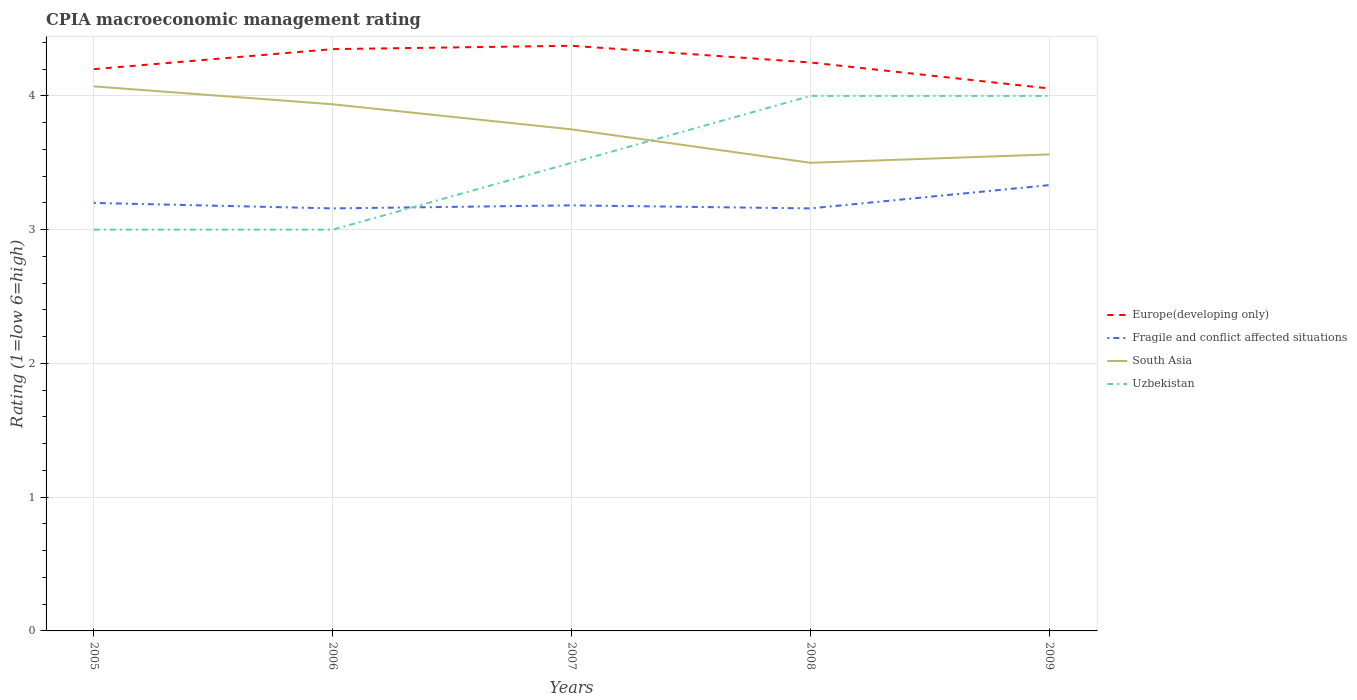How many different coloured lines are there?
Give a very brief answer. 4. Does the line corresponding to Fragile and conflict affected situations intersect with the line corresponding to Uzbekistan?
Your answer should be very brief. Yes. Is the number of lines equal to the number of legend labels?
Provide a short and direct response. Yes. Across all years, what is the maximum CPIA rating in Europe(developing only)?
Provide a short and direct response. 4.06. In which year was the CPIA rating in Uzbekistan maximum?
Keep it short and to the point. 2005. What is the difference between the highest and the second highest CPIA rating in Fragile and conflict affected situations?
Give a very brief answer. 0.17. How many lines are there?
Keep it short and to the point. 4. How many years are there in the graph?
Your response must be concise. 5. What is the difference between two consecutive major ticks on the Y-axis?
Ensure brevity in your answer.  1. Does the graph contain any zero values?
Ensure brevity in your answer.  No. What is the title of the graph?
Offer a very short reply. CPIA macroeconomic management rating. What is the label or title of the X-axis?
Provide a succinct answer. Years. What is the label or title of the Y-axis?
Offer a very short reply. Rating (1=low 6=high). What is the Rating (1=low 6=high) of Europe(developing only) in 2005?
Give a very brief answer. 4.2. What is the Rating (1=low 6=high) of Fragile and conflict affected situations in 2005?
Give a very brief answer. 3.2. What is the Rating (1=low 6=high) of South Asia in 2005?
Offer a very short reply. 4.07. What is the Rating (1=low 6=high) in Uzbekistan in 2005?
Ensure brevity in your answer.  3. What is the Rating (1=low 6=high) of Europe(developing only) in 2006?
Keep it short and to the point. 4.35. What is the Rating (1=low 6=high) in Fragile and conflict affected situations in 2006?
Your response must be concise. 3.16. What is the Rating (1=low 6=high) of South Asia in 2006?
Your answer should be compact. 3.94. What is the Rating (1=low 6=high) in Europe(developing only) in 2007?
Your answer should be compact. 4.38. What is the Rating (1=low 6=high) of Fragile and conflict affected situations in 2007?
Provide a short and direct response. 3.18. What is the Rating (1=low 6=high) in South Asia in 2007?
Give a very brief answer. 3.75. What is the Rating (1=low 6=high) of Uzbekistan in 2007?
Provide a succinct answer. 3.5. What is the Rating (1=low 6=high) in Europe(developing only) in 2008?
Provide a short and direct response. 4.25. What is the Rating (1=low 6=high) in Fragile and conflict affected situations in 2008?
Your answer should be compact. 3.16. What is the Rating (1=low 6=high) of Europe(developing only) in 2009?
Provide a short and direct response. 4.06. What is the Rating (1=low 6=high) of Fragile and conflict affected situations in 2009?
Offer a terse response. 3.33. What is the Rating (1=low 6=high) in South Asia in 2009?
Give a very brief answer. 3.56. Across all years, what is the maximum Rating (1=low 6=high) of Europe(developing only)?
Ensure brevity in your answer.  4.38. Across all years, what is the maximum Rating (1=low 6=high) in Fragile and conflict affected situations?
Make the answer very short. 3.33. Across all years, what is the maximum Rating (1=low 6=high) of South Asia?
Provide a succinct answer. 4.07. Across all years, what is the maximum Rating (1=low 6=high) of Uzbekistan?
Offer a very short reply. 4. Across all years, what is the minimum Rating (1=low 6=high) of Europe(developing only)?
Keep it short and to the point. 4.06. Across all years, what is the minimum Rating (1=low 6=high) in Fragile and conflict affected situations?
Give a very brief answer. 3.16. Across all years, what is the minimum Rating (1=low 6=high) in South Asia?
Your answer should be very brief. 3.5. Across all years, what is the minimum Rating (1=low 6=high) of Uzbekistan?
Keep it short and to the point. 3. What is the total Rating (1=low 6=high) in Europe(developing only) in the graph?
Your response must be concise. 21.23. What is the total Rating (1=low 6=high) of Fragile and conflict affected situations in the graph?
Give a very brief answer. 16.03. What is the total Rating (1=low 6=high) of South Asia in the graph?
Your answer should be compact. 18.82. What is the difference between the Rating (1=low 6=high) in Europe(developing only) in 2005 and that in 2006?
Your answer should be very brief. -0.15. What is the difference between the Rating (1=low 6=high) in Fragile and conflict affected situations in 2005 and that in 2006?
Offer a very short reply. 0.04. What is the difference between the Rating (1=low 6=high) of South Asia in 2005 and that in 2006?
Offer a very short reply. 0.13. What is the difference between the Rating (1=low 6=high) of Europe(developing only) in 2005 and that in 2007?
Provide a succinct answer. -0.17. What is the difference between the Rating (1=low 6=high) of Fragile and conflict affected situations in 2005 and that in 2007?
Ensure brevity in your answer.  0.02. What is the difference between the Rating (1=low 6=high) in South Asia in 2005 and that in 2007?
Your response must be concise. 0.32. What is the difference between the Rating (1=low 6=high) in Fragile and conflict affected situations in 2005 and that in 2008?
Your response must be concise. 0.04. What is the difference between the Rating (1=low 6=high) in South Asia in 2005 and that in 2008?
Give a very brief answer. 0.57. What is the difference between the Rating (1=low 6=high) of Uzbekistan in 2005 and that in 2008?
Your answer should be compact. -1. What is the difference between the Rating (1=low 6=high) in Europe(developing only) in 2005 and that in 2009?
Provide a short and direct response. 0.14. What is the difference between the Rating (1=low 6=high) in Fragile and conflict affected situations in 2005 and that in 2009?
Your answer should be compact. -0.13. What is the difference between the Rating (1=low 6=high) in South Asia in 2005 and that in 2009?
Provide a short and direct response. 0.51. What is the difference between the Rating (1=low 6=high) of Europe(developing only) in 2006 and that in 2007?
Ensure brevity in your answer.  -0.03. What is the difference between the Rating (1=low 6=high) in Fragile and conflict affected situations in 2006 and that in 2007?
Keep it short and to the point. -0.02. What is the difference between the Rating (1=low 6=high) in South Asia in 2006 and that in 2007?
Provide a short and direct response. 0.19. What is the difference between the Rating (1=low 6=high) of South Asia in 2006 and that in 2008?
Ensure brevity in your answer.  0.44. What is the difference between the Rating (1=low 6=high) of Uzbekistan in 2006 and that in 2008?
Ensure brevity in your answer.  -1. What is the difference between the Rating (1=low 6=high) of Europe(developing only) in 2006 and that in 2009?
Your answer should be very brief. 0.29. What is the difference between the Rating (1=low 6=high) in Fragile and conflict affected situations in 2006 and that in 2009?
Provide a succinct answer. -0.17. What is the difference between the Rating (1=low 6=high) in South Asia in 2006 and that in 2009?
Provide a succinct answer. 0.38. What is the difference between the Rating (1=low 6=high) in Fragile and conflict affected situations in 2007 and that in 2008?
Your response must be concise. 0.02. What is the difference between the Rating (1=low 6=high) of Europe(developing only) in 2007 and that in 2009?
Provide a short and direct response. 0.32. What is the difference between the Rating (1=low 6=high) in Fragile and conflict affected situations in 2007 and that in 2009?
Your answer should be compact. -0.15. What is the difference between the Rating (1=low 6=high) in South Asia in 2007 and that in 2009?
Give a very brief answer. 0.19. What is the difference between the Rating (1=low 6=high) of Europe(developing only) in 2008 and that in 2009?
Offer a terse response. 0.19. What is the difference between the Rating (1=low 6=high) of Fragile and conflict affected situations in 2008 and that in 2009?
Provide a succinct answer. -0.17. What is the difference between the Rating (1=low 6=high) of South Asia in 2008 and that in 2009?
Offer a terse response. -0.06. What is the difference between the Rating (1=low 6=high) of Uzbekistan in 2008 and that in 2009?
Offer a terse response. 0. What is the difference between the Rating (1=low 6=high) of Europe(developing only) in 2005 and the Rating (1=low 6=high) of Fragile and conflict affected situations in 2006?
Your answer should be very brief. 1.04. What is the difference between the Rating (1=low 6=high) in Europe(developing only) in 2005 and the Rating (1=low 6=high) in South Asia in 2006?
Your response must be concise. 0.26. What is the difference between the Rating (1=low 6=high) in Fragile and conflict affected situations in 2005 and the Rating (1=low 6=high) in South Asia in 2006?
Give a very brief answer. -0.74. What is the difference between the Rating (1=low 6=high) of South Asia in 2005 and the Rating (1=low 6=high) of Uzbekistan in 2006?
Offer a very short reply. 1.07. What is the difference between the Rating (1=low 6=high) of Europe(developing only) in 2005 and the Rating (1=low 6=high) of Fragile and conflict affected situations in 2007?
Your answer should be very brief. 1.02. What is the difference between the Rating (1=low 6=high) in Europe(developing only) in 2005 and the Rating (1=low 6=high) in South Asia in 2007?
Your answer should be very brief. 0.45. What is the difference between the Rating (1=low 6=high) in Europe(developing only) in 2005 and the Rating (1=low 6=high) in Uzbekistan in 2007?
Provide a short and direct response. 0.7. What is the difference between the Rating (1=low 6=high) of Fragile and conflict affected situations in 2005 and the Rating (1=low 6=high) of South Asia in 2007?
Offer a terse response. -0.55. What is the difference between the Rating (1=low 6=high) in Fragile and conflict affected situations in 2005 and the Rating (1=low 6=high) in Uzbekistan in 2007?
Provide a short and direct response. -0.3. What is the difference between the Rating (1=low 6=high) in Europe(developing only) in 2005 and the Rating (1=low 6=high) in Fragile and conflict affected situations in 2008?
Your answer should be very brief. 1.04. What is the difference between the Rating (1=low 6=high) in Europe(developing only) in 2005 and the Rating (1=low 6=high) in Uzbekistan in 2008?
Your answer should be very brief. 0.2. What is the difference between the Rating (1=low 6=high) in South Asia in 2005 and the Rating (1=low 6=high) in Uzbekistan in 2008?
Provide a succinct answer. 0.07. What is the difference between the Rating (1=low 6=high) in Europe(developing only) in 2005 and the Rating (1=low 6=high) in Fragile and conflict affected situations in 2009?
Ensure brevity in your answer.  0.87. What is the difference between the Rating (1=low 6=high) of Europe(developing only) in 2005 and the Rating (1=low 6=high) of South Asia in 2009?
Your answer should be compact. 0.64. What is the difference between the Rating (1=low 6=high) in Fragile and conflict affected situations in 2005 and the Rating (1=low 6=high) in South Asia in 2009?
Make the answer very short. -0.36. What is the difference between the Rating (1=low 6=high) in South Asia in 2005 and the Rating (1=low 6=high) in Uzbekistan in 2009?
Offer a very short reply. 0.07. What is the difference between the Rating (1=low 6=high) of Europe(developing only) in 2006 and the Rating (1=low 6=high) of Fragile and conflict affected situations in 2007?
Provide a succinct answer. 1.17. What is the difference between the Rating (1=low 6=high) of Europe(developing only) in 2006 and the Rating (1=low 6=high) of South Asia in 2007?
Offer a very short reply. 0.6. What is the difference between the Rating (1=low 6=high) of Fragile and conflict affected situations in 2006 and the Rating (1=low 6=high) of South Asia in 2007?
Offer a terse response. -0.59. What is the difference between the Rating (1=low 6=high) of Fragile and conflict affected situations in 2006 and the Rating (1=low 6=high) of Uzbekistan in 2007?
Your answer should be compact. -0.34. What is the difference between the Rating (1=low 6=high) of South Asia in 2006 and the Rating (1=low 6=high) of Uzbekistan in 2007?
Your answer should be compact. 0.44. What is the difference between the Rating (1=low 6=high) of Europe(developing only) in 2006 and the Rating (1=low 6=high) of Fragile and conflict affected situations in 2008?
Provide a short and direct response. 1.19. What is the difference between the Rating (1=low 6=high) of Fragile and conflict affected situations in 2006 and the Rating (1=low 6=high) of South Asia in 2008?
Your answer should be compact. -0.34. What is the difference between the Rating (1=low 6=high) of Fragile and conflict affected situations in 2006 and the Rating (1=low 6=high) of Uzbekistan in 2008?
Your response must be concise. -0.84. What is the difference between the Rating (1=low 6=high) of South Asia in 2006 and the Rating (1=low 6=high) of Uzbekistan in 2008?
Give a very brief answer. -0.06. What is the difference between the Rating (1=low 6=high) of Europe(developing only) in 2006 and the Rating (1=low 6=high) of Fragile and conflict affected situations in 2009?
Provide a short and direct response. 1.02. What is the difference between the Rating (1=low 6=high) in Europe(developing only) in 2006 and the Rating (1=low 6=high) in South Asia in 2009?
Your answer should be very brief. 0.79. What is the difference between the Rating (1=low 6=high) of Europe(developing only) in 2006 and the Rating (1=low 6=high) of Uzbekistan in 2009?
Give a very brief answer. 0.35. What is the difference between the Rating (1=low 6=high) of Fragile and conflict affected situations in 2006 and the Rating (1=low 6=high) of South Asia in 2009?
Keep it short and to the point. -0.4. What is the difference between the Rating (1=low 6=high) of Fragile and conflict affected situations in 2006 and the Rating (1=low 6=high) of Uzbekistan in 2009?
Ensure brevity in your answer.  -0.84. What is the difference between the Rating (1=low 6=high) of South Asia in 2006 and the Rating (1=low 6=high) of Uzbekistan in 2009?
Keep it short and to the point. -0.06. What is the difference between the Rating (1=low 6=high) of Europe(developing only) in 2007 and the Rating (1=low 6=high) of Fragile and conflict affected situations in 2008?
Make the answer very short. 1.22. What is the difference between the Rating (1=low 6=high) in Fragile and conflict affected situations in 2007 and the Rating (1=low 6=high) in South Asia in 2008?
Your response must be concise. -0.32. What is the difference between the Rating (1=low 6=high) in Fragile and conflict affected situations in 2007 and the Rating (1=low 6=high) in Uzbekistan in 2008?
Make the answer very short. -0.82. What is the difference between the Rating (1=low 6=high) in Europe(developing only) in 2007 and the Rating (1=low 6=high) in Fragile and conflict affected situations in 2009?
Your answer should be very brief. 1.04. What is the difference between the Rating (1=low 6=high) in Europe(developing only) in 2007 and the Rating (1=low 6=high) in South Asia in 2009?
Your answer should be compact. 0.81. What is the difference between the Rating (1=low 6=high) of Europe(developing only) in 2007 and the Rating (1=low 6=high) of Uzbekistan in 2009?
Your answer should be very brief. 0.38. What is the difference between the Rating (1=low 6=high) in Fragile and conflict affected situations in 2007 and the Rating (1=low 6=high) in South Asia in 2009?
Offer a terse response. -0.38. What is the difference between the Rating (1=low 6=high) in Fragile and conflict affected situations in 2007 and the Rating (1=low 6=high) in Uzbekistan in 2009?
Offer a terse response. -0.82. What is the difference between the Rating (1=low 6=high) in Europe(developing only) in 2008 and the Rating (1=low 6=high) in South Asia in 2009?
Provide a short and direct response. 0.69. What is the difference between the Rating (1=low 6=high) of Europe(developing only) in 2008 and the Rating (1=low 6=high) of Uzbekistan in 2009?
Ensure brevity in your answer.  0.25. What is the difference between the Rating (1=low 6=high) of Fragile and conflict affected situations in 2008 and the Rating (1=low 6=high) of South Asia in 2009?
Your response must be concise. -0.4. What is the difference between the Rating (1=low 6=high) of Fragile and conflict affected situations in 2008 and the Rating (1=low 6=high) of Uzbekistan in 2009?
Offer a very short reply. -0.84. What is the average Rating (1=low 6=high) of Europe(developing only) per year?
Your answer should be compact. 4.25. What is the average Rating (1=low 6=high) in Fragile and conflict affected situations per year?
Your answer should be compact. 3.21. What is the average Rating (1=low 6=high) of South Asia per year?
Provide a succinct answer. 3.76. What is the average Rating (1=low 6=high) in Uzbekistan per year?
Offer a terse response. 3.5. In the year 2005, what is the difference between the Rating (1=low 6=high) in Europe(developing only) and Rating (1=low 6=high) in South Asia?
Provide a short and direct response. 0.13. In the year 2005, what is the difference between the Rating (1=low 6=high) in Europe(developing only) and Rating (1=low 6=high) in Uzbekistan?
Provide a succinct answer. 1.2. In the year 2005, what is the difference between the Rating (1=low 6=high) of Fragile and conflict affected situations and Rating (1=low 6=high) of South Asia?
Provide a succinct answer. -0.87. In the year 2005, what is the difference between the Rating (1=low 6=high) of Fragile and conflict affected situations and Rating (1=low 6=high) of Uzbekistan?
Keep it short and to the point. 0.2. In the year 2005, what is the difference between the Rating (1=low 6=high) of South Asia and Rating (1=low 6=high) of Uzbekistan?
Provide a succinct answer. 1.07. In the year 2006, what is the difference between the Rating (1=low 6=high) in Europe(developing only) and Rating (1=low 6=high) in Fragile and conflict affected situations?
Your response must be concise. 1.19. In the year 2006, what is the difference between the Rating (1=low 6=high) of Europe(developing only) and Rating (1=low 6=high) of South Asia?
Provide a succinct answer. 0.41. In the year 2006, what is the difference between the Rating (1=low 6=high) in Europe(developing only) and Rating (1=low 6=high) in Uzbekistan?
Your answer should be compact. 1.35. In the year 2006, what is the difference between the Rating (1=low 6=high) in Fragile and conflict affected situations and Rating (1=low 6=high) in South Asia?
Provide a succinct answer. -0.78. In the year 2006, what is the difference between the Rating (1=low 6=high) of Fragile and conflict affected situations and Rating (1=low 6=high) of Uzbekistan?
Provide a succinct answer. 0.16. In the year 2006, what is the difference between the Rating (1=low 6=high) of South Asia and Rating (1=low 6=high) of Uzbekistan?
Your response must be concise. 0.94. In the year 2007, what is the difference between the Rating (1=low 6=high) of Europe(developing only) and Rating (1=low 6=high) of Fragile and conflict affected situations?
Provide a short and direct response. 1.19. In the year 2007, what is the difference between the Rating (1=low 6=high) of Europe(developing only) and Rating (1=low 6=high) of Uzbekistan?
Offer a very short reply. 0.88. In the year 2007, what is the difference between the Rating (1=low 6=high) of Fragile and conflict affected situations and Rating (1=low 6=high) of South Asia?
Make the answer very short. -0.57. In the year 2007, what is the difference between the Rating (1=low 6=high) in Fragile and conflict affected situations and Rating (1=low 6=high) in Uzbekistan?
Your answer should be compact. -0.32. In the year 2007, what is the difference between the Rating (1=low 6=high) of South Asia and Rating (1=low 6=high) of Uzbekistan?
Give a very brief answer. 0.25. In the year 2008, what is the difference between the Rating (1=low 6=high) in Europe(developing only) and Rating (1=low 6=high) in Fragile and conflict affected situations?
Keep it short and to the point. 1.09. In the year 2008, what is the difference between the Rating (1=low 6=high) of Europe(developing only) and Rating (1=low 6=high) of South Asia?
Provide a succinct answer. 0.75. In the year 2008, what is the difference between the Rating (1=low 6=high) of Europe(developing only) and Rating (1=low 6=high) of Uzbekistan?
Your response must be concise. 0.25. In the year 2008, what is the difference between the Rating (1=low 6=high) of Fragile and conflict affected situations and Rating (1=low 6=high) of South Asia?
Your response must be concise. -0.34. In the year 2008, what is the difference between the Rating (1=low 6=high) of Fragile and conflict affected situations and Rating (1=low 6=high) of Uzbekistan?
Give a very brief answer. -0.84. In the year 2009, what is the difference between the Rating (1=low 6=high) in Europe(developing only) and Rating (1=low 6=high) in Fragile and conflict affected situations?
Give a very brief answer. 0.72. In the year 2009, what is the difference between the Rating (1=low 6=high) in Europe(developing only) and Rating (1=low 6=high) in South Asia?
Ensure brevity in your answer.  0.49. In the year 2009, what is the difference between the Rating (1=low 6=high) of Europe(developing only) and Rating (1=low 6=high) of Uzbekistan?
Give a very brief answer. 0.06. In the year 2009, what is the difference between the Rating (1=low 6=high) in Fragile and conflict affected situations and Rating (1=low 6=high) in South Asia?
Your response must be concise. -0.23. In the year 2009, what is the difference between the Rating (1=low 6=high) in South Asia and Rating (1=low 6=high) in Uzbekistan?
Your answer should be compact. -0.44. What is the ratio of the Rating (1=low 6=high) in Europe(developing only) in 2005 to that in 2006?
Offer a terse response. 0.97. What is the ratio of the Rating (1=low 6=high) in Fragile and conflict affected situations in 2005 to that in 2006?
Your response must be concise. 1.01. What is the ratio of the Rating (1=low 6=high) in South Asia in 2005 to that in 2006?
Offer a terse response. 1.03. What is the ratio of the Rating (1=low 6=high) in Uzbekistan in 2005 to that in 2006?
Provide a short and direct response. 1. What is the ratio of the Rating (1=low 6=high) in Fragile and conflict affected situations in 2005 to that in 2007?
Provide a short and direct response. 1.01. What is the ratio of the Rating (1=low 6=high) in South Asia in 2005 to that in 2007?
Your response must be concise. 1.09. What is the ratio of the Rating (1=low 6=high) of Uzbekistan in 2005 to that in 2007?
Ensure brevity in your answer.  0.86. What is the ratio of the Rating (1=low 6=high) of Fragile and conflict affected situations in 2005 to that in 2008?
Your answer should be very brief. 1.01. What is the ratio of the Rating (1=low 6=high) in South Asia in 2005 to that in 2008?
Provide a succinct answer. 1.16. What is the ratio of the Rating (1=low 6=high) of Uzbekistan in 2005 to that in 2008?
Offer a very short reply. 0.75. What is the ratio of the Rating (1=low 6=high) in Europe(developing only) in 2005 to that in 2009?
Provide a short and direct response. 1.04. What is the ratio of the Rating (1=low 6=high) of South Asia in 2005 to that in 2009?
Your response must be concise. 1.14. What is the ratio of the Rating (1=low 6=high) of Uzbekistan in 2005 to that in 2009?
Ensure brevity in your answer.  0.75. What is the ratio of the Rating (1=low 6=high) in Europe(developing only) in 2006 to that in 2007?
Keep it short and to the point. 0.99. What is the ratio of the Rating (1=low 6=high) of South Asia in 2006 to that in 2007?
Offer a terse response. 1.05. What is the ratio of the Rating (1=low 6=high) of Europe(developing only) in 2006 to that in 2008?
Your response must be concise. 1.02. What is the ratio of the Rating (1=low 6=high) in Fragile and conflict affected situations in 2006 to that in 2008?
Offer a very short reply. 1. What is the ratio of the Rating (1=low 6=high) in South Asia in 2006 to that in 2008?
Give a very brief answer. 1.12. What is the ratio of the Rating (1=low 6=high) in Europe(developing only) in 2006 to that in 2009?
Ensure brevity in your answer.  1.07. What is the ratio of the Rating (1=low 6=high) of Fragile and conflict affected situations in 2006 to that in 2009?
Keep it short and to the point. 0.95. What is the ratio of the Rating (1=low 6=high) in South Asia in 2006 to that in 2009?
Your answer should be compact. 1.11. What is the ratio of the Rating (1=low 6=high) of Europe(developing only) in 2007 to that in 2008?
Ensure brevity in your answer.  1.03. What is the ratio of the Rating (1=low 6=high) in South Asia in 2007 to that in 2008?
Ensure brevity in your answer.  1.07. What is the ratio of the Rating (1=low 6=high) of Uzbekistan in 2007 to that in 2008?
Your answer should be very brief. 0.88. What is the ratio of the Rating (1=low 6=high) of Europe(developing only) in 2007 to that in 2009?
Offer a terse response. 1.08. What is the ratio of the Rating (1=low 6=high) of Fragile and conflict affected situations in 2007 to that in 2009?
Provide a succinct answer. 0.95. What is the ratio of the Rating (1=low 6=high) of South Asia in 2007 to that in 2009?
Keep it short and to the point. 1.05. What is the ratio of the Rating (1=low 6=high) of Uzbekistan in 2007 to that in 2009?
Your answer should be compact. 0.88. What is the ratio of the Rating (1=low 6=high) of Europe(developing only) in 2008 to that in 2009?
Provide a succinct answer. 1.05. What is the ratio of the Rating (1=low 6=high) of Fragile and conflict affected situations in 2008 to that in 2009?
Provide a short and direct response. 0.95. What is the ratio of the Rating (1=low 6=high) of South Asia in 2008 to that in 2009?
Give a very brief answer. 0.98. What is the ratio of the Rating (1=low 6=high) of Uzbekistan in 2008 to that in 2009?
Make the answer very short. 1. What is the difference between the highest and the second highest Rating (1=low 6=high) of Europe(developing only)?
Make the answer very short. 0.03. What is the difference between the highest and the second highest Rating (1=low 6=high) in Fragile and conflict affected situations?
Ensure brevity in your answer.  0.13. What is the difference between the highest and the second highest Rating (1=low 6=high) of South Asia?
Provide a succinct answer. 0.13. What is the difference between the highest and the lowest Rating (1=low 6=high) in Europe(developing only)?
Keep it short and to the point. 0.32. What is the difference between the highest and the lowest Rating (1=low 6=high) of Fragile and conflict affected situations?
Keep it short and to the point. 0.17. 